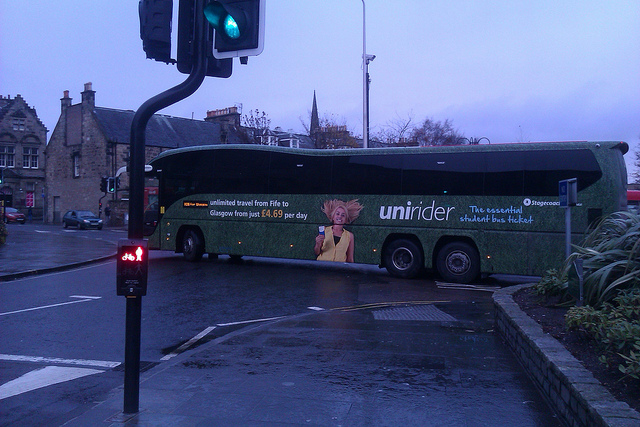Please extract the text content from this image. unirider The student ticket essential E4.69 day just from to Fire from II 